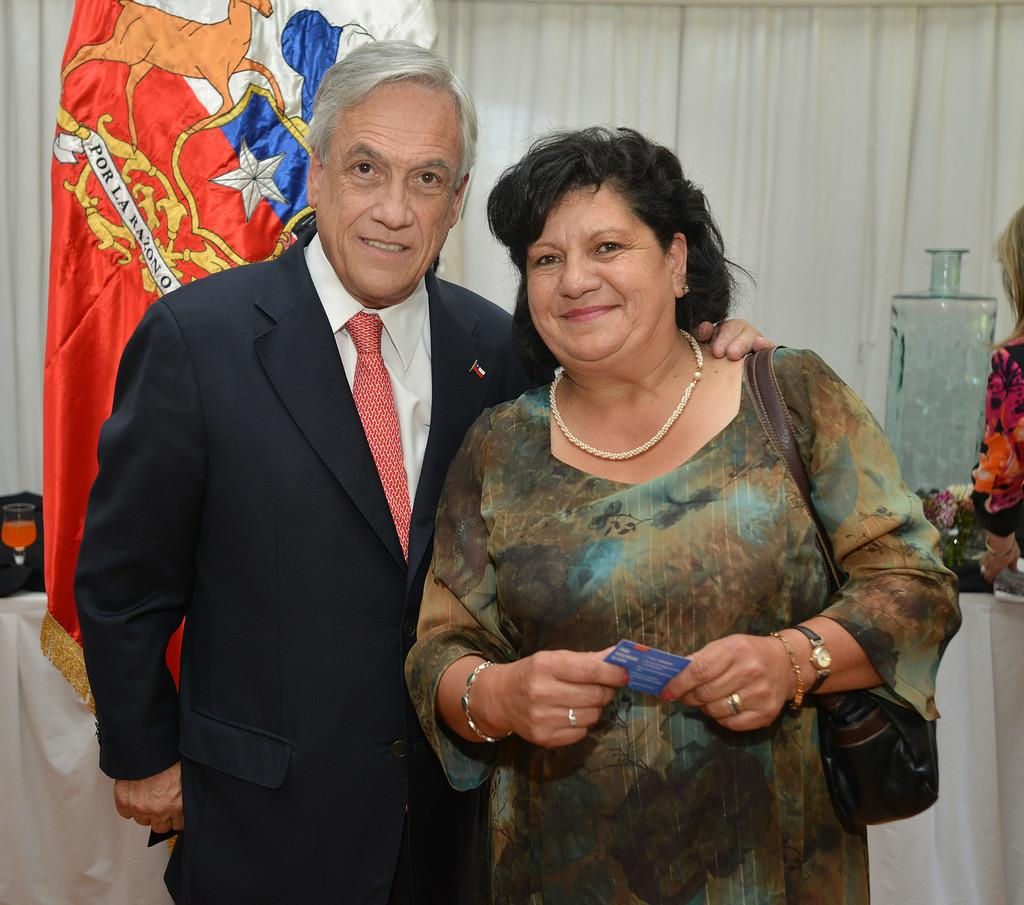How many people are present in the image? There are two people, a man and a woman, present in the image. What are the man and the woman doing in the image? Both the man and the woman are standing on the floor. What can be seen in the background of the image? There are curtains and a glass container in the background of the image. What type of disgust can be seen on the man's face in the image? There is no indication of disgust on the man's face in the image. Is there a hospital visible in the image? There is no hospital present in the image. 